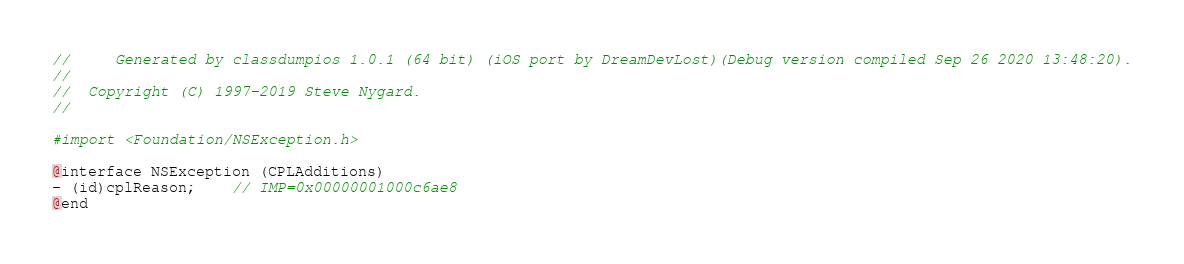Convert code to text. <code><loc_0><loc_0><loc_500><loc_500><_C_>//     Generated by classdumpios 1.0.1 (64 bit) (iOS port by DreamDevLost)(Debug version compiled Sep 26 2020 13:48:20).
//
//  Copyright (C) 1997-2019 Steve Nygard.
//

#import <Foundation/NSException.h>

@interface NSException (CPLAdditions)
- (id)cplReason;	// IMP=0x00000001000c6ae8
@end

</code> 